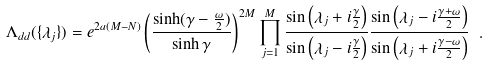Convert formula to latex. <formula><loc_0><loc_0><loc_500><loc_500>\Lambda _ { d d } ( \{ \lambda _ { j } \} ) = e ^ { 2 a ( M - N ) } \left ( \frac { \sinh ( \gamma - \frac { \omega } { 2 } ) } { \sinh \gamma } \right ) ^ { 2 M } \prod _ { j = 1 } ^ { M } \frac { \sin \left ( \lambda _ { j } + i \frac { \gamma } { 2 } \right ) } { \sin \left ( \lambda _ { j } - i \frac { \gamma } { 2 } \right ) } \frac { \sin \left ( \lambda _ { j } - i \frac { \gamma + \omega } { 2 } \right ) } { \sin \left ( \lambda _ { j } + i \frac { \gamma - \omega } { 2 } \right ) } \ .</formula> 